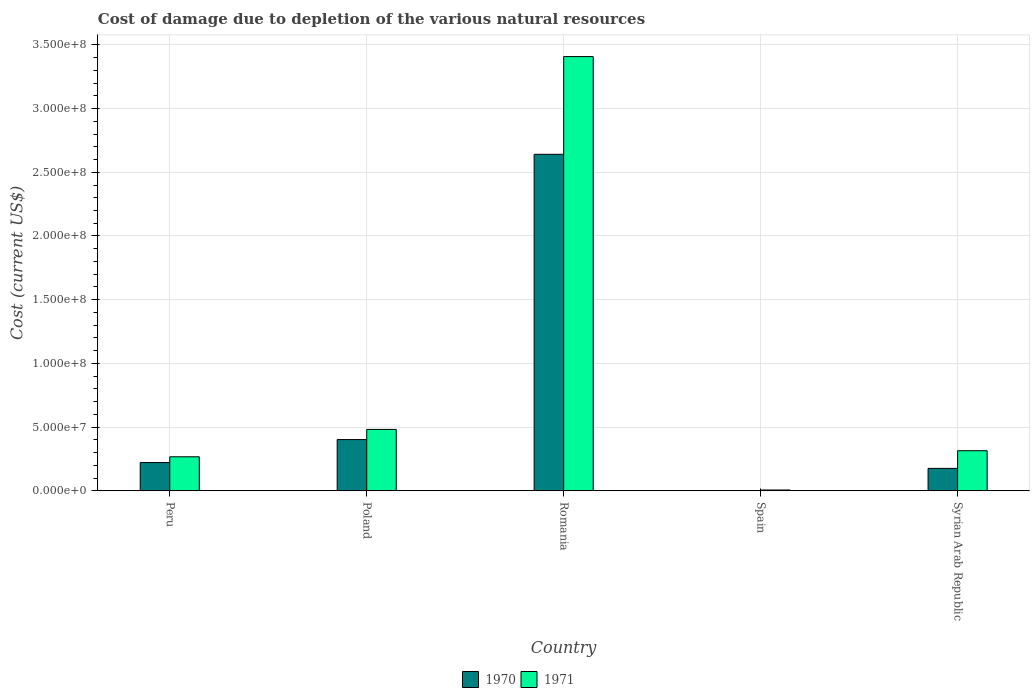How many different coloured bars are there?
Your answer should be compact. 2. Are the number of bars on each tick of the X-axis equal?
Provide a succinct answer. Yes. How many bars are there on the 1st tick from the left?
Ensure brevity in your answer.  2. How many bars are there on the 5th tick from the right?
Your answer should be very brief. 2. What is the label of the 5th group of bars from the left?
Offer a very short reply. Syrian Arab Republic. In how many cases, is the number of bars for a given country not equal to the number of legend labels?
Ensure brevity in your answer.  0. What is the cost of damage caused due to the depletion of various natural resources in 1971 in Romania?
Offer a very short reply. 3.41e+08. Across all countries, what is the maximum cost of damage caused due to the depletion of various natural resources in 1970?
Offer a terse response. 2.64e+08. Across all countries, what is the minimum cost of damage caused due to the depletion of various natural resources in 1971?
Offer a terse response. 6.25e+05. In which country was the cost of damage caused due to the depletion of various natural resources in 1971 maximum?
Provide a succinct answer. Romania. What is the total cost of damage caused due to the depletion of various natural resources in 1971 in the graph?
Provide a short and direct response. 4.48e+08. What is the difference between the cost of damage caused due to the depletion of various natural resources in 1970 in Peru and that in Poland?
Make the answer very short. -1.80e+07. What is the difference between the cost of damage caused due to the depletion of various natural resources in 1970 in Syrian Arab Republic and the cost of damage caused due to the depletion of various natural resources in 1971 in Romania?
Your answer should be very brief. -3.23e+08. What is the average cost of damage caused due to the depletion of various natural resources in 1971 per country?
Keep it short and to the point. 8.95e+07. What is the difference between the cost of damage caused due to the depletion of various natural resources of/in 1970 and cost of damage caused due to the depletion of various natural resources of/in 1971 in Syrian Arab Republic?
Give a very brief answer. -1.39e+07. In how many countries, is the cost of damage caused due to the depletion of various natural resources in 1970 greater than 130000000 US$?
Provide a short and direct response. 1. What is the ratio of the cost of damage caused due to the depletion of various natural resources in 1971 in Romania to that in Spain?
Make the answer very short. 545.26. Is the cost of damage caused due to the depletion of various natural resources in 1971 in Peru less than that in Spain?
Provide a succinct answer. No. What is the difference between the highest and the second highest cost of damage caused due to the depletion of various natural resources in 1971?
Keep it short and to the point. -1.67e+07. What is the difference between the highest and the lowest cost of damage caused due to the depletion of various natural resources in 1970?
Provide a short and direct response. 2.64e+08. What does the 2nd bar from the right in Peru represents?
Ensure brevity in your answer.  1970. Are the values on the major ticks of Y-axis written in scientific E-notation?
Provide a short and direct response. Yes. Does the graph contain any zero values?
Ensure brevity in your answer.  No. How many legend labels are there?
Your answer should be compact. 2. What is the title of the graph?
Offer a terse response. Cost of damage due to depletion of the various natural resources. What is the label or title of the X-axis?
Your response must be concise. Country. What is the label or title of the Y-axis?
Provide a succinct answer. Cost (current US$). What is the Cost (current US$) in 1970 in Peru?
Your answer should be very brief. 2.22e+07. What is the Cost (current US$) in 1971 in Peru?
Your answer should be compact. 2.67e+07. What is the Cost (current US$) of 1970 in Poland?
Your response must be concise. 4.02e+07. What is the Cost (current US$) in 1971 in Poland?
Offer a very short reply. 4.82e+07. What is the Cost (current US$) of 1970 in Romania?
Offer a terse response. 2.64e+08. What is the Cost (current US$) in 1971 in Romania?
Provide a succinct answer. 3.41e+08. What is the Cost (current US$) of 1970 in Spain?
Keep it short and to the point. 1.78e+04. What is the Cost (current US$) of 1971 in Spain?
Your answer should be very brief. 6.25e+05. What is the Cost (current US$) of 1970 in Syrian Arab Republic?
Ensure brevity in your answer.  1.76e+07. What is the Cost (current US$) of 1971 in Syrian Arab Republic?
Make the answer very short. 3.14e+07. Across all countries, what is the maximum Cost (current US$) in 1970?
Ensure brevity in your answer.  2.64e+08. Across all countries, what is the maximum Cost (current US$) in 1971?
Give a very brief answer. 3.41e+08. Across all countries, what is the minimum Cost (current US$) in 1970?
Ensure brevity in your answer.  1.78e+04. Across all countries, what is the minimum Cost (current US$) in 1971?
Provide a succinct answer. 6.25e+05. What is the total Cost (current US$) of 1970 in the graph?
Provide a succinct answer. 3.44e+08. What is the total Cost (current US$) in 1971 in the graph?
Offer a terse response. 4.48e+08. What is the difference between the Cost (current US$) of 1970 in Peru and that in Poland?
Offer a terse response. -1.80e+07. What is the difference between the Cost (current US$) of 1971 in Peru and that in Poland?
Your answer should be compact. -2.15e+07. What is the difference between the Cost (current US$) in 1970 in Peru and that in Romania?
Provide a short and direct response. -2.42e+08. What is the difference between the Cost (current US$) in 1971 in Peru and that in Romania?
Your response must be concise. -3.14e+08. What is the difference between the Cost (current US$) in 1970 in Peru and that in Spain?
Offer a terse response. 2.21e+07. What is the difference between the Cost (current US$) of 1971 in Peru and that in Spain?
Provide a succinct answer. 2.61e+07. What is the difference between the Cost (current US$) of 1970 in Peru and that in Syrian Arab Republic?
Give a very brief answer. 4.57e+06. What is the difference between the Cost (current US$) in 1971 in Peru and that in Syrian Arab Republic?
Your response must be concise. -4.77e+06. What is the difference between the Cost (current US$) in 1970 in Poland and that in Romania?
Ensure brevity in your answer.  -2.24e+08. What is the difference between the Cost (current US$) of 1971 in Poland and that in Romania?
Offer a terse response. -2.93e+08. What is the difference between the Cost (current US$) in 1970 in Poland and that in Spain?
Make the answer very short. 4.02e+07. What is the difference between the Cost (current US$) in 1971 in Poland and that in Spain?
Keep it short and to the point. 4.75e+07. What is the difference between the Cost (current US$) of 1970 in Poland and that in Syrian Arab Republic?
Keep it short and to the point. 2.26e+07. What is the difference between the Cost (current US$) of 1971 in Poland and that in Syrian Arab Republic?
Offer a very short reply. 1.67e+07. What is the difference between the Cost (current US$) of 1970 in Romania and that in Spain?
Offer a terse response. 2.64e+08. What is the difference between the Cost (current US$) in 1971 in Romania and that in Spain?
Your answer should be compact. 3.40e+08. What is the difference between the Cost (current US$) in 1970 in Romania and that in Syrian Arab Republic?
Give a very brief answer. 2.47e+08. What is the difference between the Cost (current US$) of 1971 in Romania and that in Syrian Arab Republic?
Your answer should be compact. 3.09e+08. What is the difference between the Cost (current US$) in 1970 in Spain and that in Syrian Arab Republic?
Your response must be concise. -1.76e+07. What is the difference between the Cost (current US$) in 1971 in Spain and that in Syrian Arab Republic?
Keep it short and to the point. -3.08e+07. What is the difference between the Cost (current US$) of 1970 in Peru and the Cost (current US$) of 1971 in Poland?
Your response must be concise. -2.60e+07. What is the difference between the Cost (current US$) in 1970 in Peru and the Cost (current US$) in 1971 in Romania?
Provide a short and direct response. -3.19e+08. What is the difference between the Cost (current US$) in 1970 in Peru and the Cost (current US$) in 1971 in Spain?
Make the answer very short. 2.15e+07. What is the difference between the Cost (current US$) in 1970 in Peru and the Cost (current US$) in 1971 in Syrian Arab Republic?
Provide a succinct answer. -9.29e+06. What is the difference between the Cost (current US$) of 1970 in Poland and the Cost (current US$) of 1971 in Romania?
Make the answer very short. -3.01e+08. What is the difference between the Cost (current US$) of 1970 in Poland and the Cost (current US$) of 1971 in Spain?
Offer a very short reply. 3.96e+07. What is the difference between the Cost (current US$) of 1970 in Poland and the Cost (current US$) of 1971 in Syrian Arab Republic?
Your response must be concise. 8.75e+06. What is the difference between the Cost (current US$) in 1970 in Romania and the Cost (current US$) in 1971 in Spain?
Provide a short and direct response. 2.63e+08. What is the difference between the Cost (current US$) in 1970 in Romania and the Cost (current US$) in 1971 in Syrian Arab Republic?
Keep it short and to the point. 2.33e+08. What is the difference between the Cost (current US$) in 1970 in Spain and the Cost (current US$) in 1971 in Syrian Arab Republic?
Give a very brief answer. -3.14e+07. What is the average Cost (current US$) of 1970 per country?
Provide a succinct answer. 6.88e+07. What is the average Cost (current US$) of 1971 per country?
Keep it short and to the point. 8.95e+07. What is the difference between the Cost (current US$) of 1970 and Cost (current US$) of 1971 in Peru?
Your answer should be compact. -4.53e+06. What is the difference between the Cost (current US$) of 1970 and Cost (current US$) of 1971 in Poland?
Give a very brief answer. -7.95e+06. What is the difference between the Cost (current US$) in 1970 and Cost (current US$) in 1971 in Romania?
Your answer should be compact. -7.67e+07. What is the difference between the Cost (current US$) in 1970 and Cost (current US$) in 1971 in Spain?
Make the answer very short. -6.07e+05. What is the difference between the Cost (current US$) of 1970 and Cost (current US$) of 1971 in Syrian Arab Republic?
Offer a terse response. -1.39e+07. What is the ratio of the Cost (current US$) of 1970 in Peru to that in Poland?
Provide a succinct answer. 0.55. What is the ratio of the Cost (current US$) in 1971 in Peru to that in Poland?
Your response must be concise. 0.55. What is the ratio of the Cost (current US$) of 1970 in Peru to that in Romania?
Your response must be concise. 0.08. What is the ratio of the Cost (current US$) in 1971 in Peru to that in Romania?
Provide a succinct answer. 0.08. What is the ratio of the Cost (current US$) in 1970 in Peru to that in Spain?
Offer a very short reply. 1245.27. What is the ratio of the Cost (current US$) of 1971 in Peru to that in Spain?
Keep it short and to the point. 42.69. What is the ratio of the Cost (current US$) in 1970 in Peru to that in Syrian Arab Republic?
Your answer should be compact. 1.26. What is the ratio of the Cost (current US$) in 1971 in Peru to that in Syrian Arab Republic?
Your response must be concise. 0.85. What is the ratio of the Cost (current US$) of 1970 in Poland to that in Romania?
Offer a very short reply. 0.15. What is the ratio of the Cost (current US$) in 1971 in Poland to that in Romania?
Offer a very short reply. 0.14. What is the ratio of the Cost (current US$) of 1970 in Poland to that in Spain?
Give a very brief answer. 2259.53. What is the ratio of the Cost (current US$) of 1971 in Poland to that in Spain?
Your answer should be very brief. 77.04. What is the ratio of the Cost (current US$) of 1970 in Poland to that in Syrian Arab Republic?
Your response must be concise. 2.29. What is the ratio of the Cost (current US$) of 1971 in Poland to that in Syrian Arab Republic?
Your answer should be compact. 1.53. What is the ratio of the Cost (current US$) in 1970 in Romania to that in Spain?
Make the answer very short. 1.48e+04. What is the ratio of the Cost (current US$) of 1971 in Romania to that in Spain?
Offer a very short reply. 545.26. What is the ratio of the Cost (current US$) of 1970 in Romania to that in Syrian Arab Republic?
Your answer should be compact. 15.02. What is the ratio of the Cost (current US$) in 1971 in Romania to that in Syrian Arab Republic?
Ensure brevity in your answer.  10.84. What is the ratio of the Cost (current US$) in 1971 in Spain to that in Syrian Arab Republic?
Your answer should be compact. 0.02. What is the difference between the highest and the second highest Cost (current US$) in 1970?
Offer a very short reply. 2.24e+08. What is the difference between the highest and the second highest Cost (current US$) in 1971?
Your answer should be very brief. 2.93e+08. What is the difference between the highest and the lowest Cost (current US$) in 1970?
Keep it short and to the point. 2.64e+08. What is the difference between the highest and the lowest Cost (current US$) of 1971?
Your response must be concise. 3.40e+08. 